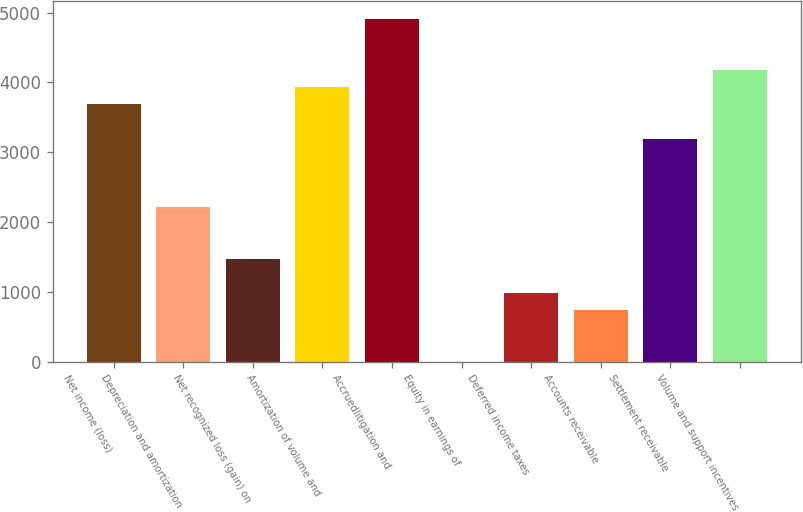<chart> <loc_0><loc_0><loc_500><loc_500><bar_chart><fcel>Net income (loss)<fcel>Depreciation and amortization<fcel>Net recognized loss (gain) on<fcel>Amortization of volume and<fcel>Accruedlitigation and<fcel>Equity in earnings of<fcel>Deferred income taxes<fcel>Accounts receivable<fcel>Settlement receivable<fcel>Volume and support incentives<nl><fcel>3686.5<fcel>2212.3<fcel>1475.2<fcel>3932.2<fcel>4915<fcel>1<fcel>983.8<fcel>738.1<fcel>3195.1<fcel>4177.9<nl></chart> 